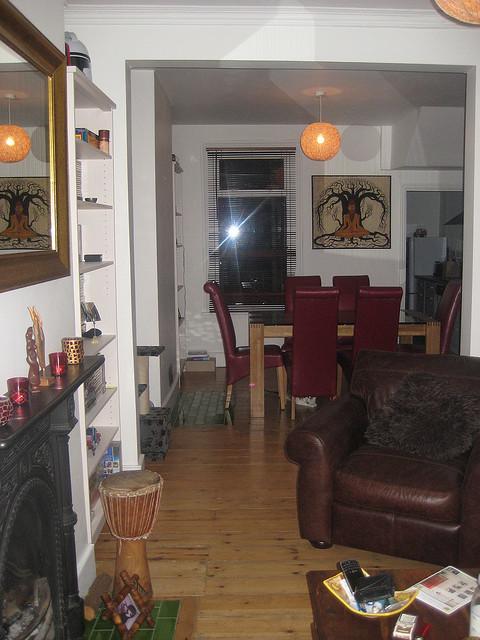Was the flash used to take this picture?
Write a very short answer. Yes. What is the chair made out of?
Quick response, please. Leather. Was it taken at night?
Give a very brief answer. Yes. What musical instrument is shown in this room?
Keep it brief. Drum. 